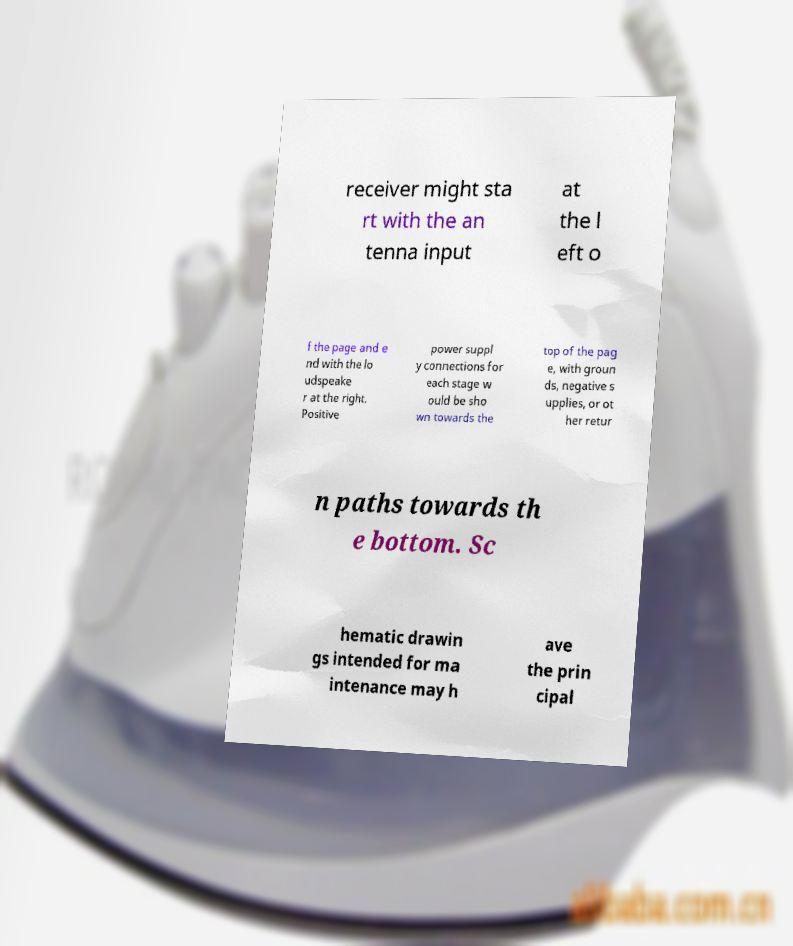Could you extract and type out the text from this image? receiver might sta rt with the an tenna input at the l eft o f the page and e nd with the lo udspeake r at the right. Positive power suppl y connections for each stage w ould be sho wn towards the top of the pag e, with groun ds, negative s upplies, or ot her retur n paths towards th e bottom. Sc hematic drawin gs intended for ma intenance may h ave the prin cipal 